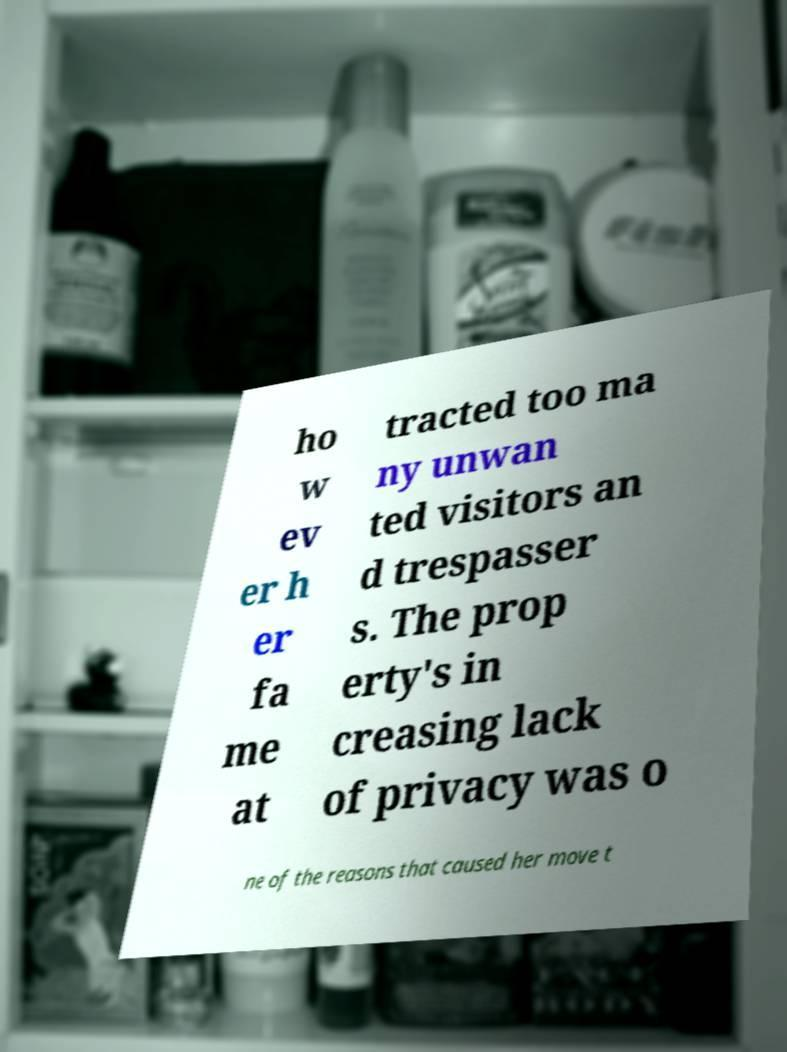Could you assist in decoding the text presented in this image and type it out clearly? ho w ev er h er fa me at tracted too ma ny unwan ted visitors an d trespasser s. The prop erty's in creasing lack of privacy was o ne of the reasons that caused her move t 